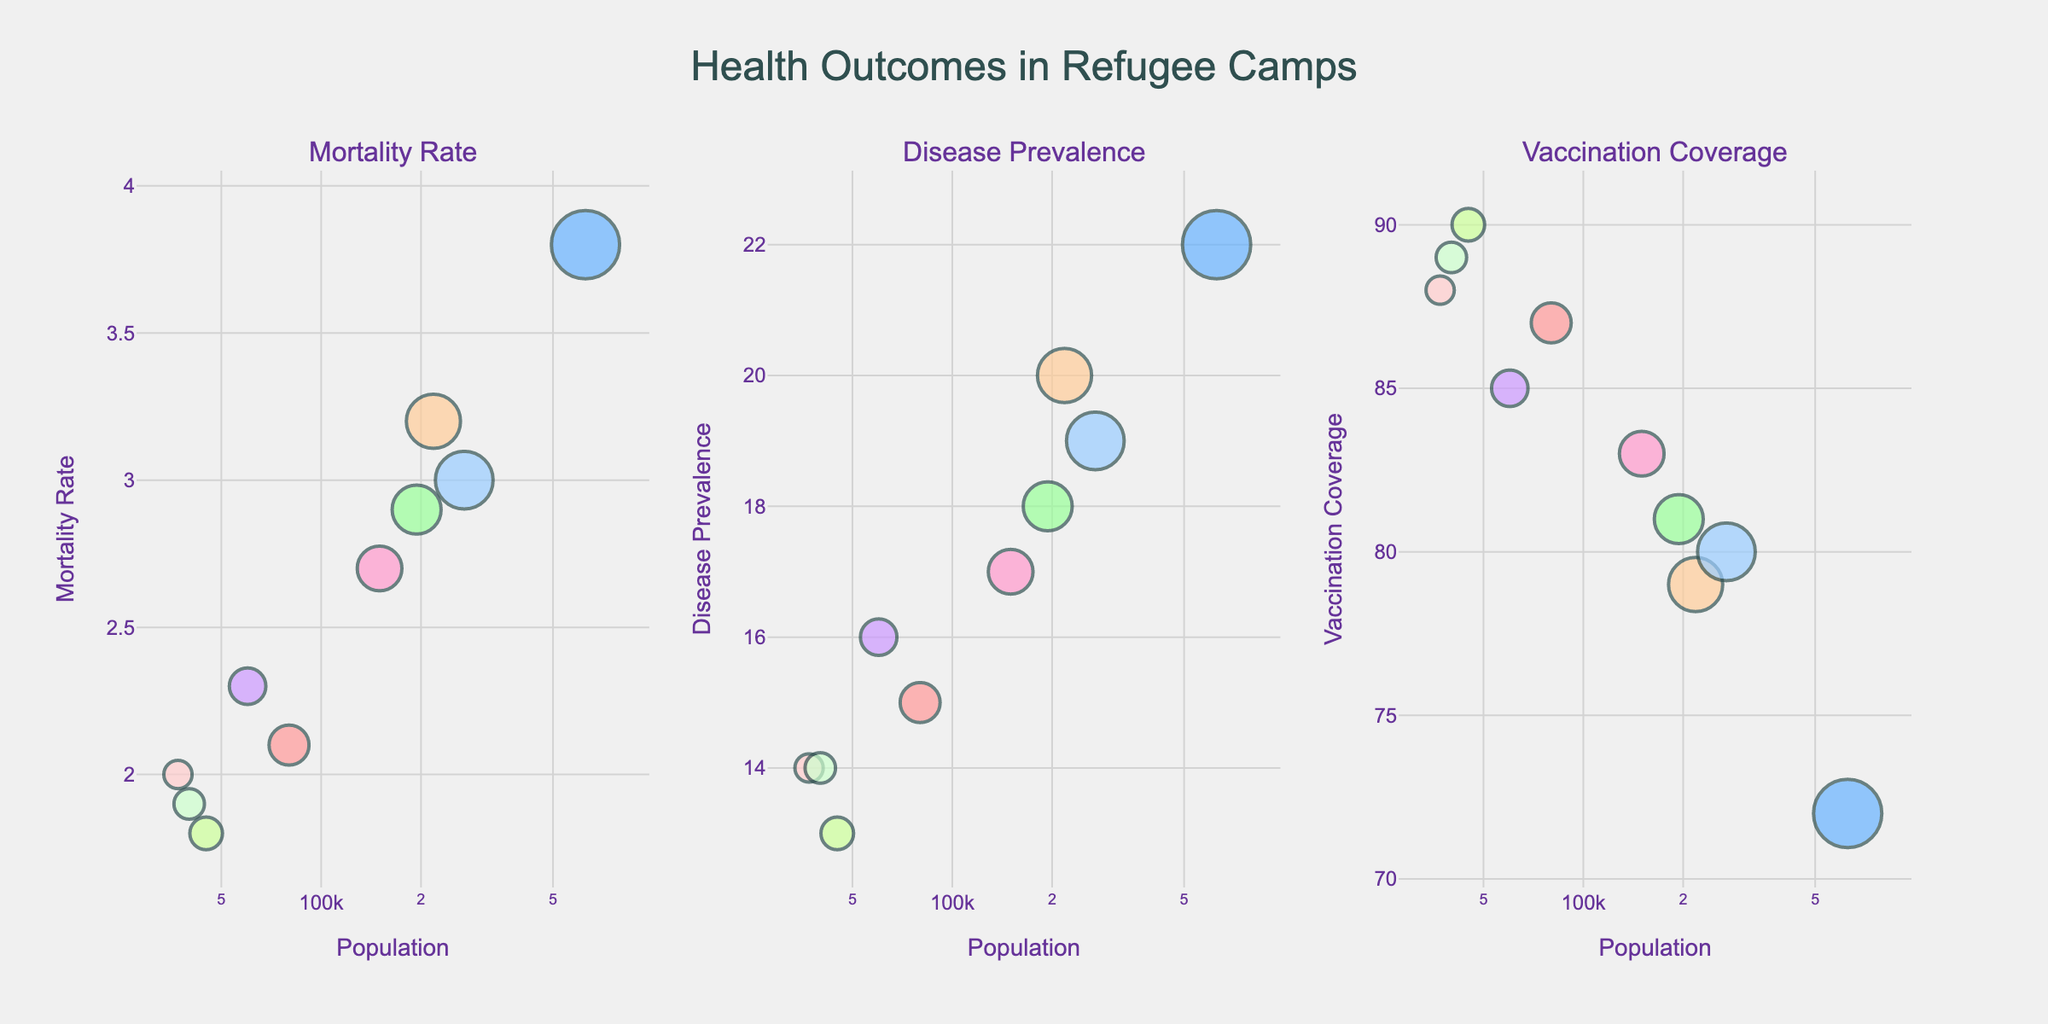what is the title of the chart? The chart's title is generally located at the top center of the figure. It explicitly states "Health Outcomes in Refugee Camps" in this case.
Answer: Health Outcomes in Refugee Camps How many refugee camps are depicted in the chart? Each camp is represented by a bubble in all three subplots, and we can count them. There are 10 bubbles in each subplot, corresponding to 10 refugee camps.
Answer: 10 Which refugee camp has the highest mortality rate? By identifying the bubble at the maximum y-value in the Mortality Rate subplot and hovering over it, we see that Kutupalong (Bangladesh) has the highest mortality rate.
Answer: Kutupalong (Bangladesh) What’s the trend observed in vaccination coverage with respect to the population? In the Vaccination Coverage subplot, the bubbles tend to show higher y-values (vaccination coverage) at various x-values (population) consistently without a clear increasing or decreasing trend.
Answer: No clear trend Between Zaatari (Jordan) and Azraq (Jordan), which camp has a higher vaccinaton coverage and by how much? In the Vaccination Coverage subplot, Zaatari (Jordan) has a coverage rate of 87%, while Azraq (Jordan) has 89%. To find the difference, we calculate 89 - 87.
Answer: Azraq (Jordan) by 2% Does camp size correlate with mortality rate? In the Mortality Rate subplot, by observing bubbles along the x-axis (population) and y-axis (mortality rate), we do not observe a strong correlation; camps of all sizes have varied mortality rates.
Answer: No strong correlation Which camp has the largest number of medical facilities and what’s its disease prevalence? The bubble's size corresponds to medical facilities; the largest bubble in each subplot denotes the camp with the most facilities. Kutupalong (Bangladesh) has the largest size bubble, corresponding to a Disease Prevalence of 22%.
Answer: Kutupalong (Bangladesh); 22% What’s the median vaccination coverage among these refugee camps? To find the median, we list the vaccination coverages in order: [72, 79, 80, 81, 83, 85, 87, 88, 89, 90]. The median will be the average of the 5th and 6th values: (83 + 85) / 2.
Answer: 84% Comparing Zaatari (Jordan) and Kakuma (Kenya), which camp has a higher mortality rate? By comparing the Mortality Rate subplot, Zaatari (Jordan) has a rate of 2.1, while Kakuma (Kenya) has a rate of 2.9.
Answer: Kakuma (Kenya) Is there a camp with relatively low population and low disease prevalence? In the Disease Prevalence subplot, look for a small x-value (population) and a small y-value (disease prevalence). Kilis (Turkey), with 45,000 people and 13% disease prevalence, fits this description.
Answer: Kilis (Turkey) 